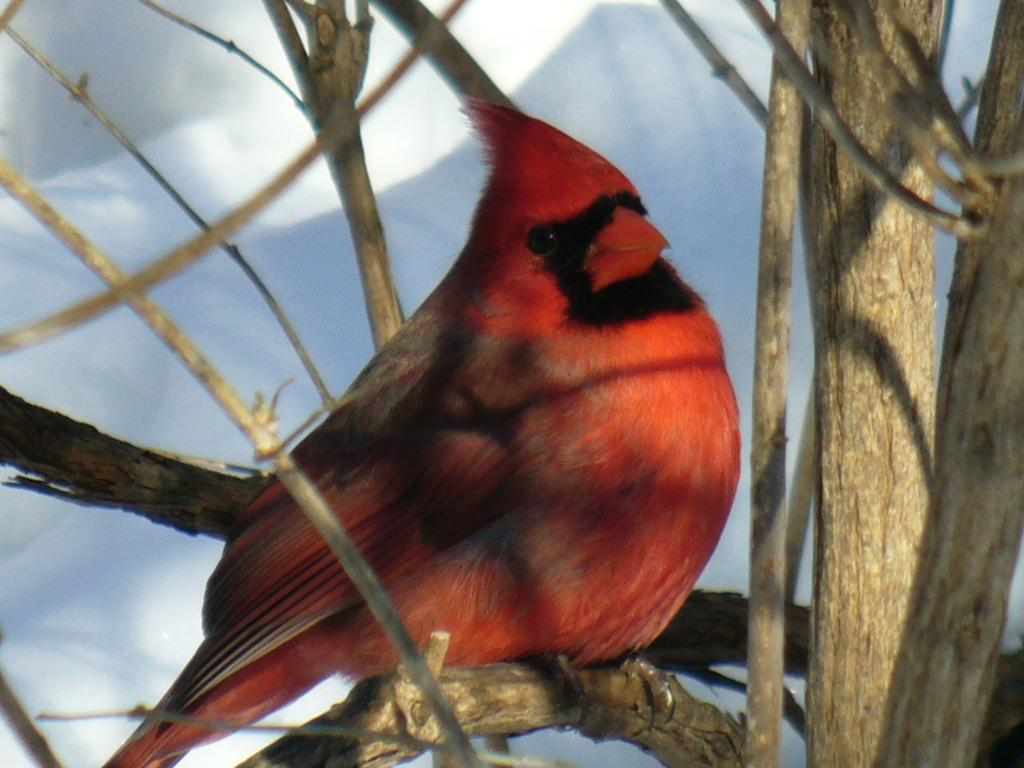What type of animal is in the image? There is a bird in the image. What colors can be seen on the bird? The bird has red and black colors. Where is the bird located in the image? The bird is on a tree branch. What color is the background of the image? The background of the image is white. What type of drug is the bird using in the image? There is no drug present in the image, and the bird is not using any substance. How many eggs can be seen in the image? There are no eggs visible in the image; it only features a bird on a tree branch. 